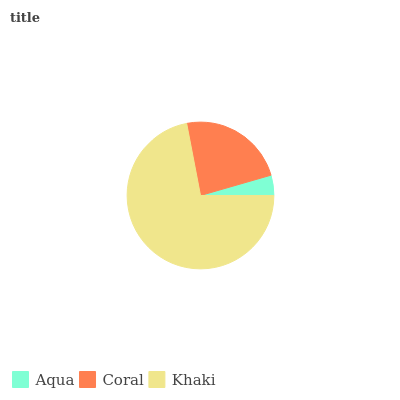Is Aqua the minimum?
Answer yes or no. Yes. Is Khaki the maximum?
Answer yes or no. Yes. Is Coral the minimum?
Answer yes or no. No. Is Coral the maximum?
Answer yes or no. No. Is Coral greater than Aqua?
Answer yes or no. Yes. Is Aqua less than Coral?
Answer yes or no. Yes. Is Aqua greater than Coral?
Answer yes or no. No. Is Coral less than Aqua?
Answer yes or no. No. Is Coral the high median?
Answer yes or no. Yes. Is Coral the low median?
Answer yes or no. Yes. Is Khaki the high median?
Answer yes or no. No. Is Khaki the low median?
Answer yes or no. No. 